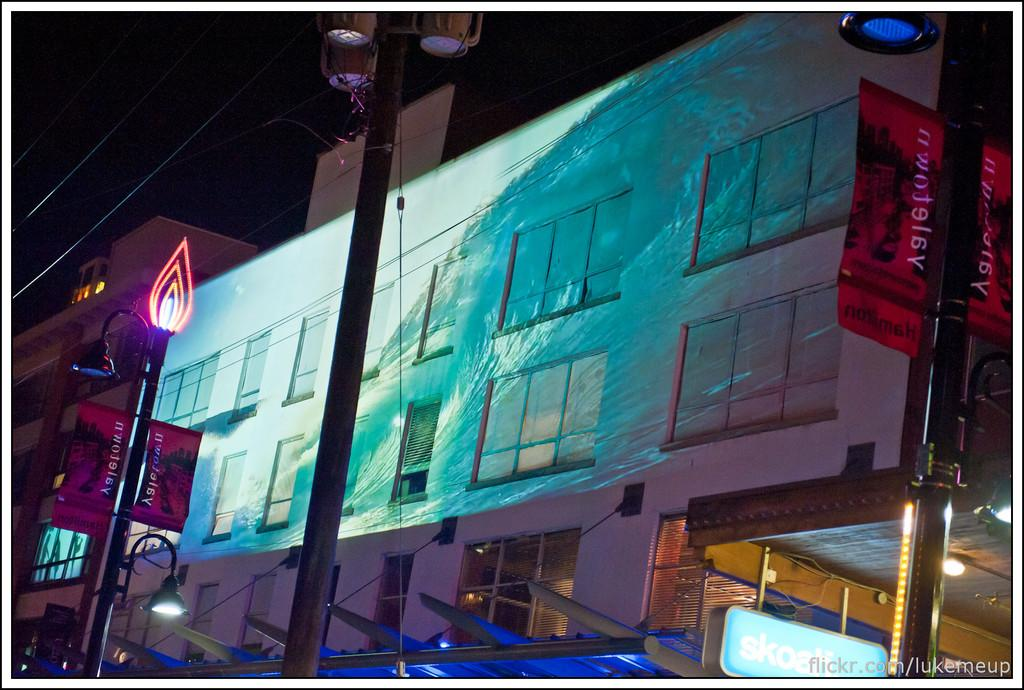What type of structure is present in the image? There is a small building in the image. What feature can be observed on the building? The building has window glasses. What is the color of the lamp post in the image? The lamp post in the image is black. What else can be seen in the image besides the building and lamp post? Cables are visible in the image. How many spots can be seen on the building in the image? There are no spots visible on the building in the image. What type of building is present in the image? The type of building is not specified in the image, only its size is mentioned. 